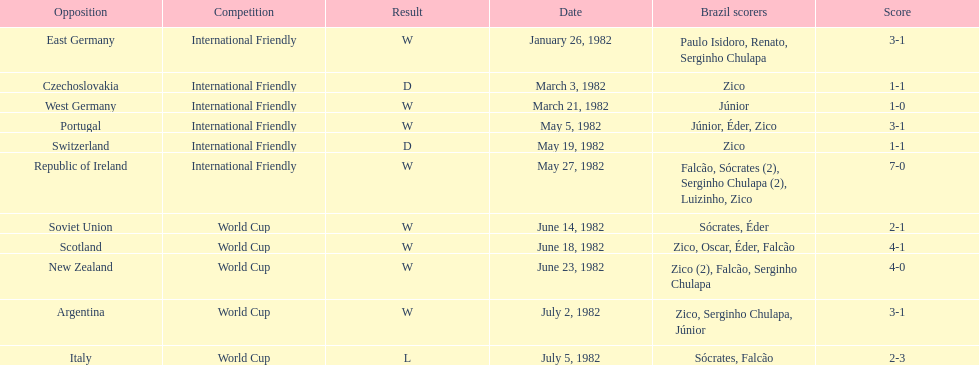How many games did this team play in 1982? 11. 